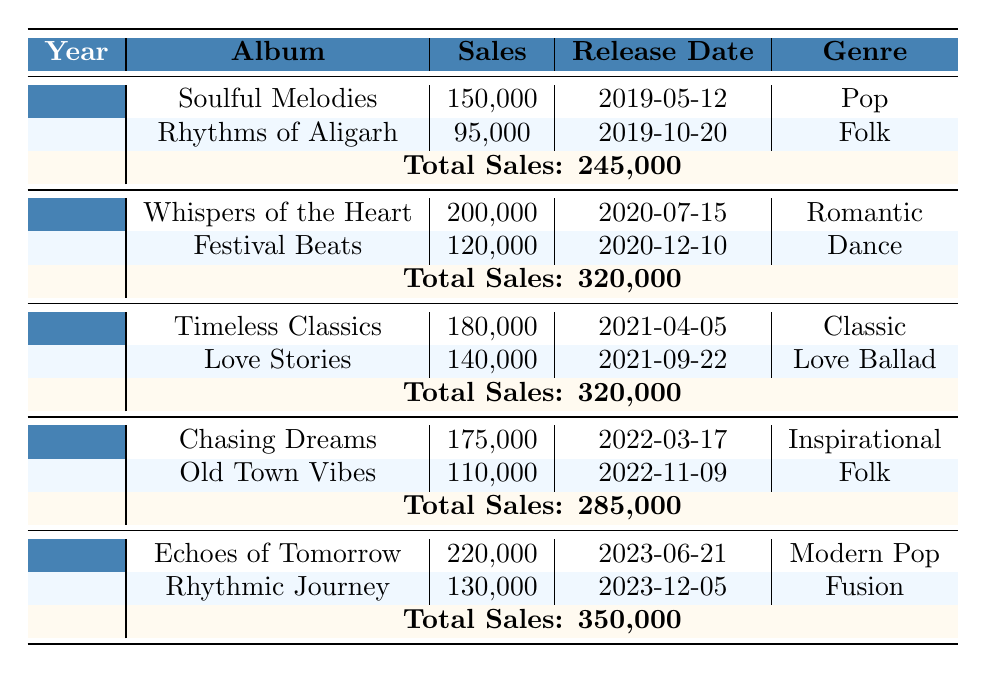What was the highest-selling album of Mohd Sharia in 2023? The albums released in 2023 are "Echoes of Tomorrow" and "Rhythmic Journey." The sales for "Echoes of Tomorrow" are 220,000, and "Rhythmic Journey" has sales of 130,000. Since 220,000 is higher than 130,000, "Echoes of Tomorrow" is the highest-selling album in 2023.
Answer: Echoes of Tomorrow How many albums were released in 2021? In 2021, there are two albums listed: "Timeless Classics" and "Love Stories." Since both albums are mentioned, we conclude that two albums were released in 2021.
Answer: 2 What was the total sales of all albums in 2020? The total sales for all albums in 2020 is explicitly stated in the table as 320,000, which combines the sales of the two albums released that year.
Answer: 320,000 Which year had the least total sales? Comparing the total sales for each year from 2019 (245,000), 2020 (320,000), 2021 (320,000), 2022 (285,000), and 2023 (350,000), 2019 has the lowest total sales. Thus, 2019 is the year with the least total sales.
Answer: 2019 Was the album "Soulful Melodies" more successful than "Chasing Dreams"? "Soulful Melodies" had sales of 150,000, and "Chasing Dreams" had sales of 175,000. Since 175,000 is greater than 150,000, "Chasing Dreams" was more successful than "Soulful Melodies."
Answer: No What are the total sales for albums released between 2022 and 2023? The total sales for 2022 are 285,000 and for 2023 are 350,000. To find the combined sales, add these two amounts together: 285,000 + 350,000 = 635,000. Therefore, the total sales for albums released between 2022 and 2023 is 635,000.
Answer: 635,000 Which genre had the highest album sales in 2023? In 2023, the albums released were "Echoes of Tomorrow" (Modern Pop) and "Rhythmic Journey" (Fusion). The sales for "Echoes of Tomorrow" are 220,000, and for "Rhythmic Journey" are 130,000. The genre with the highest sales is thus Modern Pop, as it corresponds to the highest-selling album.
Answer: Modern Pop How much more did Mohd Sharia sell in 2023 compared to 2021? In 2023, total sales were 350,000, and in 2021 it was 320,000. To find the difference, subtract the 2021 sales from the 2023 sales: 350,000 - 320,000 = 30,000. Therefore, Mohd Sharia sold 30,000 more in 2023 than in 2021.
Answer: 30,000 